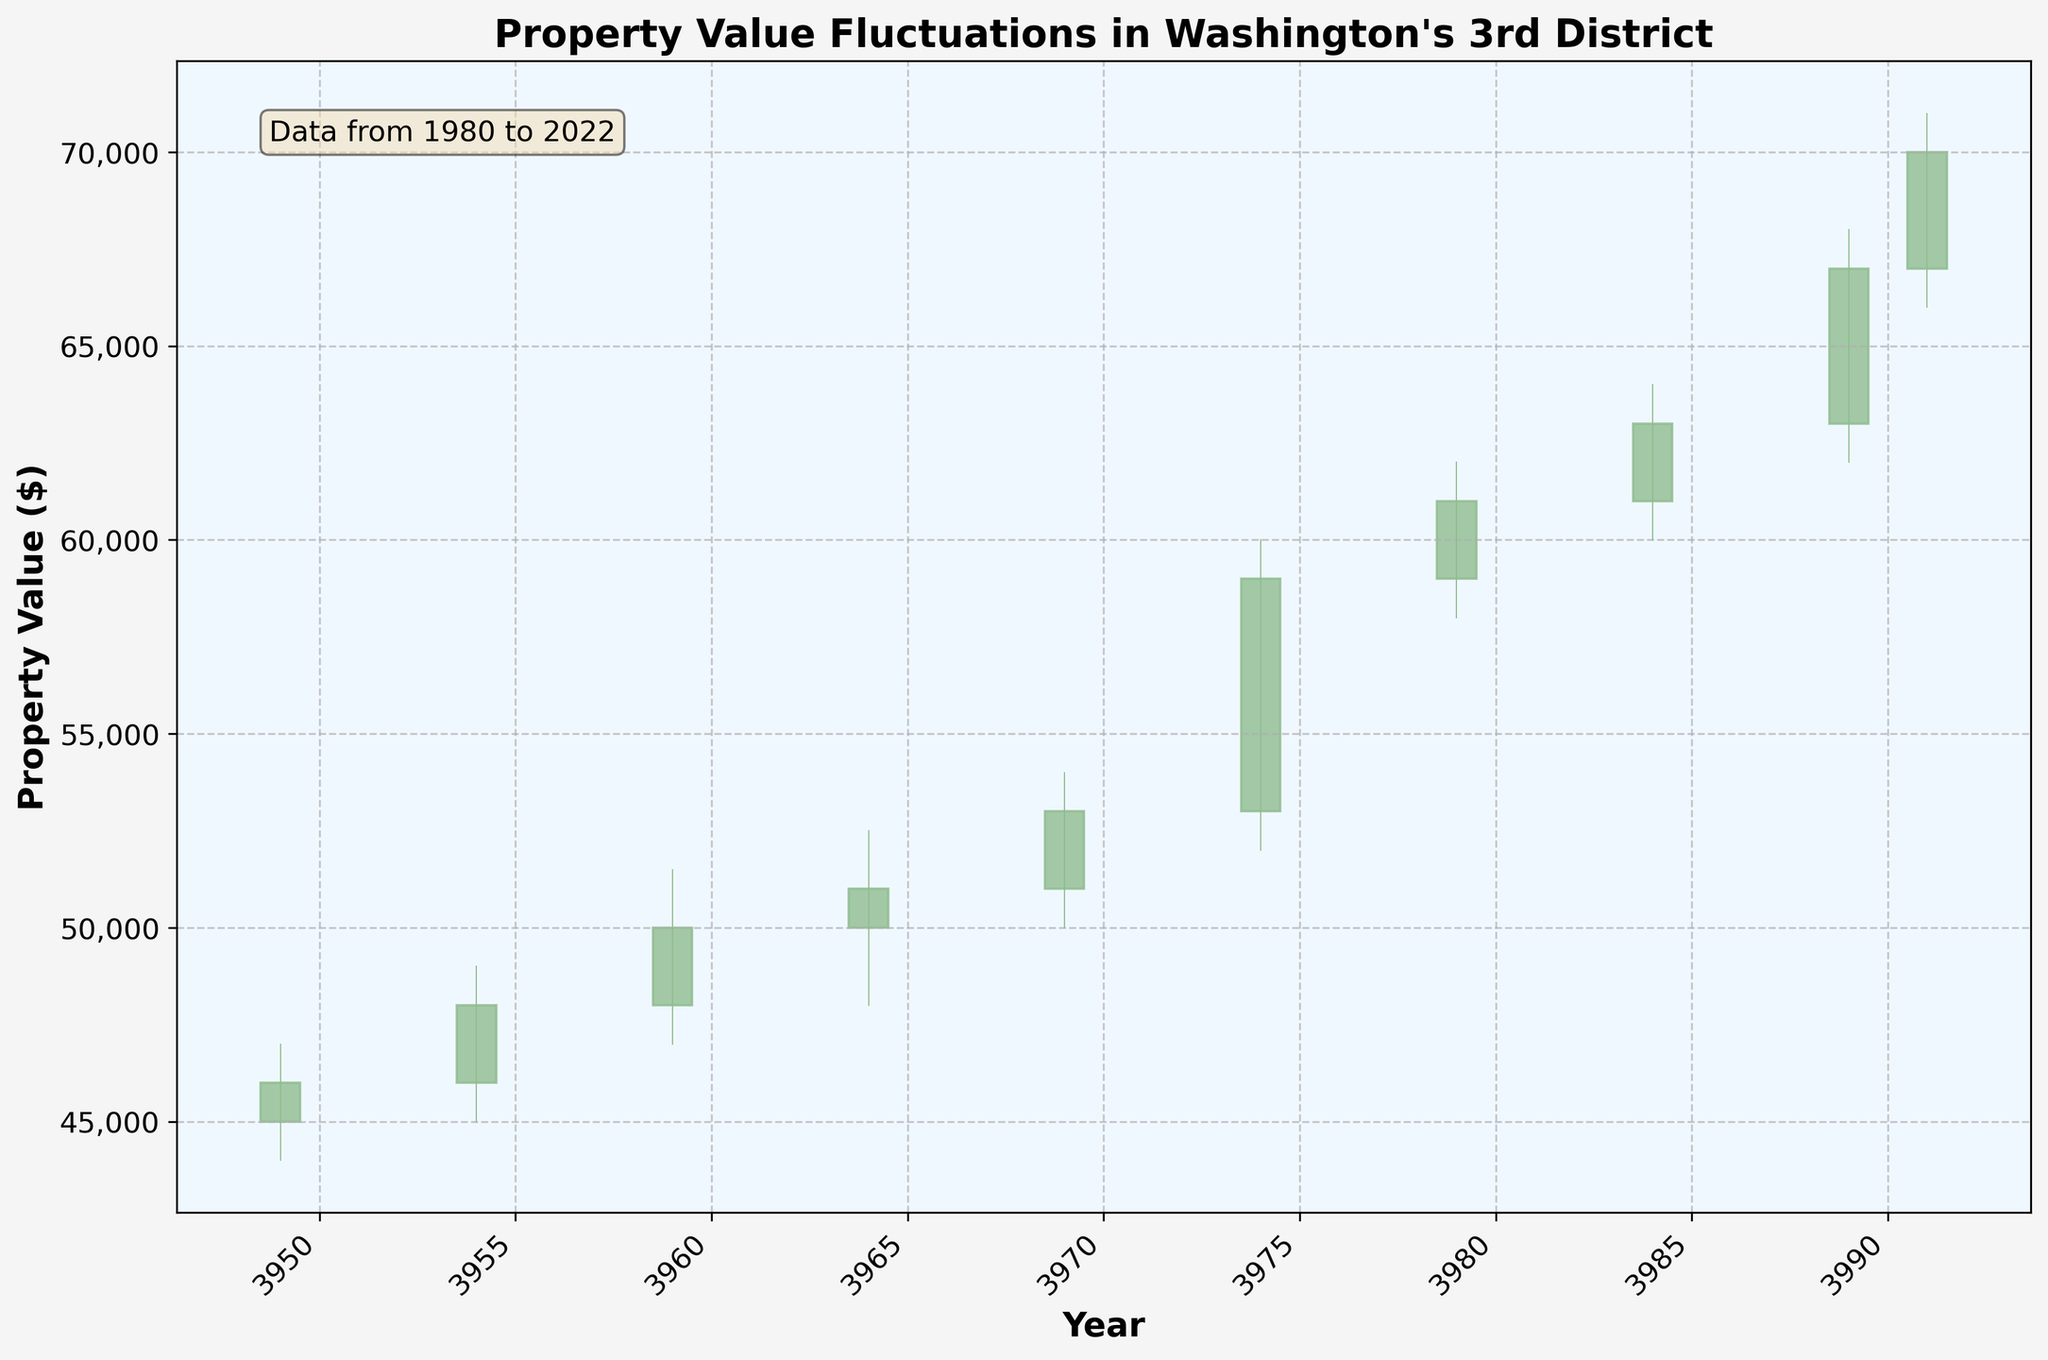what is the title of the plot? The title of the plot is located above the graphical representation. It describes the content and focus of the plot.
Answer: Property Value Fluctuations in Washington's 3rd District How often are the x-axis labels marked? The x-axis labels mark the years in intervals that can be estimated by observing the distribution of the tick marks along the x-axis.
Answer: Every 5 years Which year had the highest closing property value? By examining the closing values on the candlestick plot, we identify the year corresponding to the highest peak of the closing property values.
Answer: 2022 What is the lowest property value reached between 1980 and 2022? To find the lowest value, observe the lowest point touched by any candlestick wick throughout the timeline on the plot.
Answer: $44,000 Calculate the average closing property value over the entire period. Sum up all the closing values (46000, 48000, 50000, 51000, 53000, 59000, 61000, 63000, 67000, 70000) and then divide by the number of data points (10). The calculation steps are: (46000 + 48000 + 50000 + 51000 + 53000 + 59000 + 61000 + 63000 + 67000 + 70000) / 10.
Answer: $56,900 Which decade saw the greatest increase in property value? Compare the opening value of the first year to the closing value of the last year within each decade and determine which decade had the highest increase.
Answer: 2000s Compare the property values in 2005 and 2010. Which year had a higher closing value and by how much? The closing value of 2005 is $59,000, and for 2010 it is $61,000. Calculate the difference by subtracting the 2005 value from the 2010 value: 61000 - 59000.
Answer: 2010 had a higher value by $2,000 What is the color used to represent increasing property values? The color indicative of an increase in property values can be identified by looking at the candlestick bodies that are increasing (open < close).
Answer: Light green How did property values change from their opening value in 1980 to their closing value in 2022? Compare the opening value in 1980 ($45,000) to the closing value in 2022 ($70,000) to see the increase: 70000 - 45000.
Answer: Increased by $25,000 What can you infer about the volatility of property values in the district between 2005 and 2010? The volatility can be assessed by observing the lengths of the wicks and the heights of the candlesticks between these years. Longer wicks and taller candlesticks imply greater volatility.
Answer: High volatility 